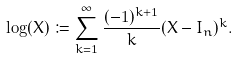Convert formula to latex. <formula><loc_0><loc_0><loc_500><loc_500>\log ( X ) \coloneqq \sum _ { k = 1 } ^ { \infty } \frac { ( - 1 ) ^ { k + 1 } } { k } ( X - I _ { n } ) ^ { k } .</formula> 